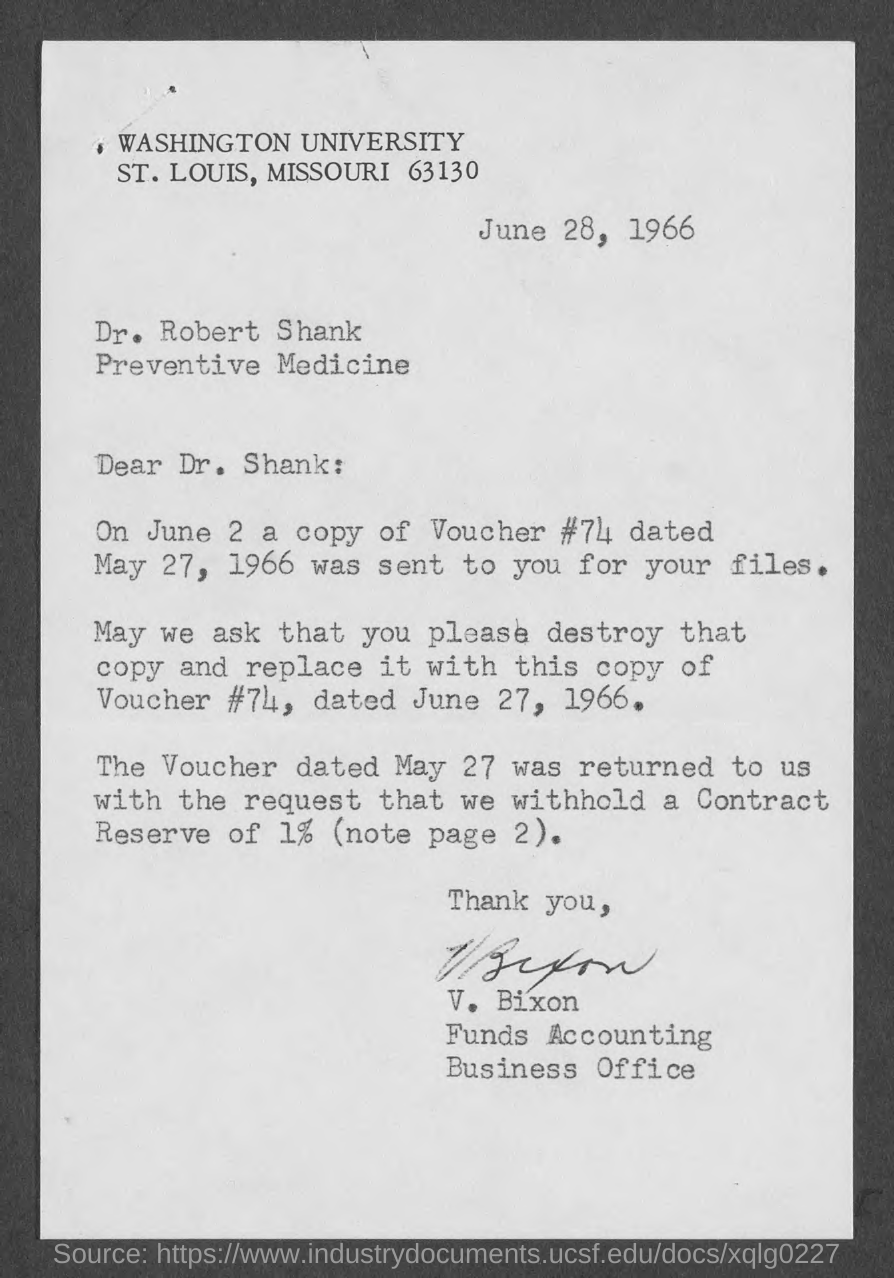What is the Date mentioned in the top of he document ?
Provide a short and direct response. June 28, 1966. Who is the Memorandum addressed to ?
Your response must be concise. Dr. Robert Shank. Who is written this letter ?
Make the answer very short. V. Bixon. 